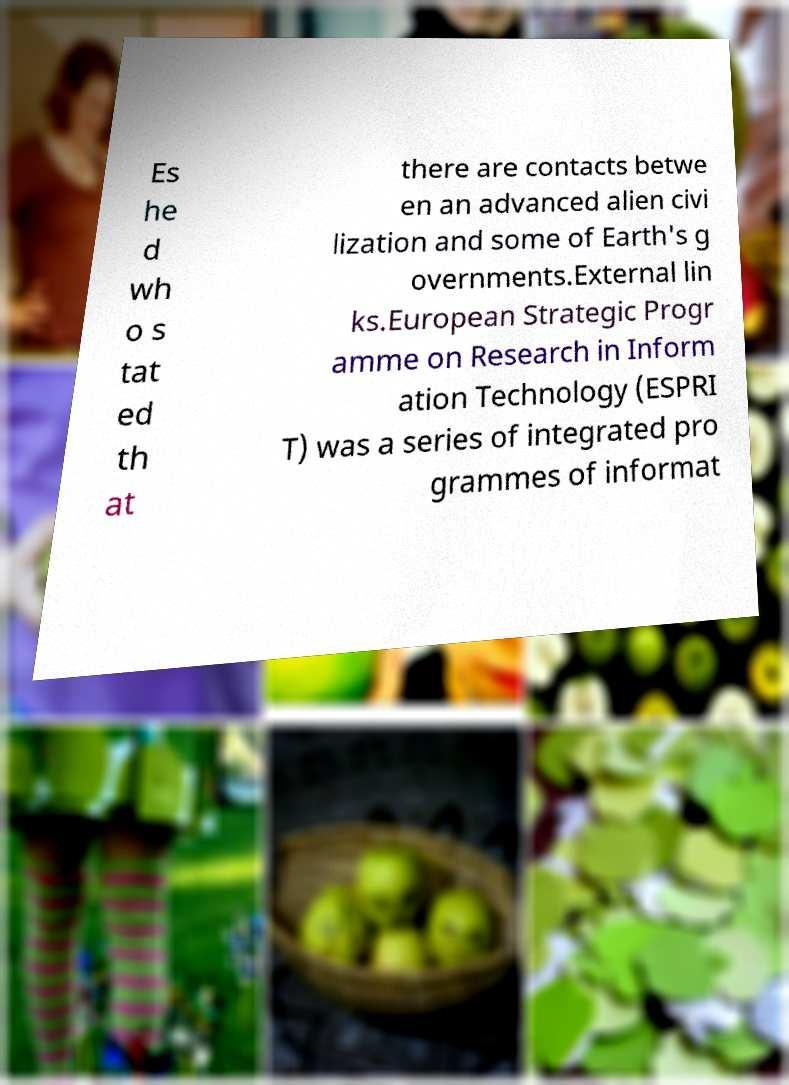There's text embedded in this image that I need extracted. Can you transcribe it verbatim? Es he d wh o s tat ed th at there are contacts betwe en an advanced alien civi lization and some of Earth's g overnments.External lin ks.European Strategic Progr amme on Research in Inform ation Technology (ESPRI T) was a series of integrated pro grammes of informat 